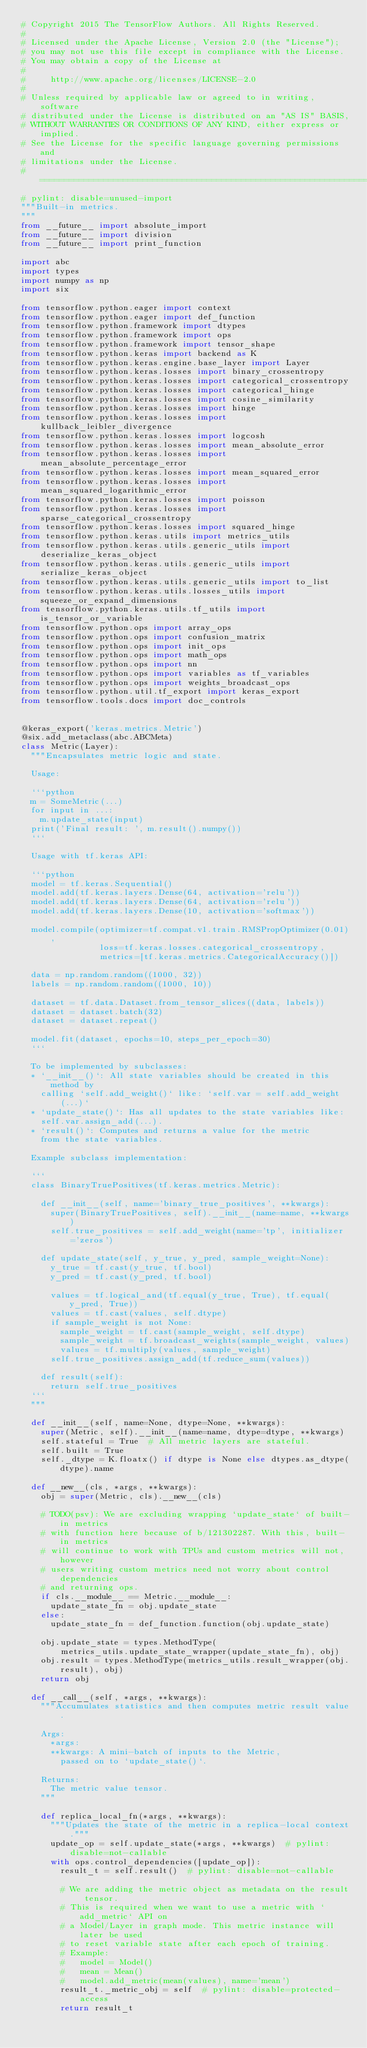Convert code to text. <code><loc_0><loc_0><loc_500><loc_500><_Python_># Copyright 2015 The TensorFlow Authors. All Rights Reserved.
#
# Licensed under the Apache License, Version 2.0 (the "License");
# you may not use this file except in compliance with the License.
# You may obtain a copy of the License at
#
#     http://www.apache.org/licenses/LICENSE-2.0
#
# Unless required by applicable law or agreed to in writing, software
# distributed under the License is distributed on an "AS IS" BASIS,
# WITHOUT WARRANTIES OR CONDITIONS OF ANY KIND, either express or implied.
# See the License for the specific language governing permissions and
# limitations under the License.
# ==============================================================================
# pylint: disable=unused-import
"""Built-in metrics.
"""
from __future__ import absolute_import
from __future__ import division
from __future__ import print_function

import abc
import types
import numpy as np
import six

from tensorflow.python.eager import context
from tensorflow.python.eager import def_function
from tensorflow.python.framework import dtypes
from tensorflow.python.framework import ops
from tensorflow.python.framework import tensor_shape
from tensorflow.python.keras import backend as K
from tensorflow.python.keras.engine.base_layer import Layer
from tensorflow.python.keras.losses import binary_crossentropy
from tensorflow.python.keras.losses import categorical_crossentropy
from tensorflow.python.keras.losses import categorical_hinge
from tensorflow.python.keras.losses import cosine_similarity
from tensorflow.python.keras.losses import hinge
from tensorflow.python.keras.losses import kullback_leibler_divergence
from tensorflow.python.keras.losses import logcosh
from tensorflow.python.keras.losses import mean_absolute_error
from tensorflow.python.keras.losses import mean_absolute_percentage_error
from tensorflow.python.keras.losses import mean_squared_error
from tensorflow.python.keras.losses import mean_squared_logarithmic_error
from tensorflow.python.keras.losses import poisson
from tensorflow.python.keras.losses import sparse_categorical_crossentropy
from tensorflow.python.keras.losses import squared_hinge
from tensorflow.python.keras.utils import metrics_utils
from tensorflow.python.keras.utils.generic_utils import deserialize_keras_object
from tensorflow.python.keras.utils.generic_utils import serialize_keras_object
from tensorflow.python.keras.utils.generic_utils import to_list
from tensorflow.python.keras.utils.losses_utils import squeeze_or_expand_dimensions
from tensorflow.python.keras.utils.tf_utils import is_tensor_or_variable
from tensorflow.python.ops import array_ops
from tensorflow.python.ops import confusion_matrix
from tensorflow.python.ops import init_ops
from tensorflow.python.ops import math_ops
from tensorflow.python.ops import nn
from tensorflow.python.ops import variables as tf_variables
from tensorflow.python.ops import weights_broadcast_ops
from tensorflow.python.util.tf_export import keras_export
from tensorflow.tools.docs import doc_controls


@keras_export('keras.metrics.Metric')
@six.add_metaclass(abc.ABCMeta)
class Metric(Layer):
  """Encapsulates metric logic and state.

  Usage:

  ```python
  m = SomeMetric(...)
  for input in ...:
    m.update_state(input)
  print('Final result: ', m.result().numpy())
  ```

  Usage with tf.keras API:

  ```python
  model = tf.keras.Sequential()
  model.add(tf.keras.layers.Dense(64, activation='relu'))
  model.add(tf.keras.layers.Dense(64, activation='relu'))
  model.add(tf.keras.layers.Dense(10, activation='softmax'))

  model.compile(optimizer=tf.compat.v1.train.RMSPropOptimizer(0.01),
                loss=tf.keras.losses.categorical_crossentropy,
                metrics=[tf.keras.metrics.CategoricalAccuracy()])

  data = np.random.random((1000, 32))
  labels = np.random.random((1000, 10))

  dataset = tf.data.Dataset.from_tensor_slices((data, labels))
  dataset = dataset.batch(32)
  dataset = dataset.repeat()

  model.fit(dataset, epochs=10, steps_per_epoch=30)
  ```

  To be implemented by subclasses:
  * `__init__()`: All state variables should be created in this method by
    calling `self.add_weight()` like: `self.var = self.add_weight(...)`
  * `update_state()`: Has all updates to the state variables like:
    self.var.assign_add(...).
  * `result()`: Computes and returns a value for the metric
    from the state variables.

  Example subclass implementation:

  ```
  class BinaryTruePositives(tf.keras.metrics.Metric):

    def __init__(self, name='binary_true_positives', **kwargs):
      super(BinaryTruePositives, self).__init__(name=name, **kwargs)
      self.true_positives = self.add_weight(name='tp', initializer='zeros')

    def update_state(self, y_true, y_pred, sample_weight=None):
      y_true = tf.cast(y_true, tf.bool)
      y_pred = tf.cast(y_pred, tf.bool)

      values = tf.logical_and(tf.equal(y_true, True), tf.equal(y_pred, True))
      values = tf.cast(values, self.dtype)
      if sample_weight is not None:
        sample_weight = tf.cast(sample_weight, self.dtype)
        sample_weight = tf.broadcast_weights(sample_weight, values)
        values = tf.multiply(values, sample_weight)
      self.true_positives.assign_add(tf.reduce_sum(values))

    def result(self):
      return self.true_positives
  ```
  """

  def __init__(self, name=None, dtype=None, **kwargs):
    super(Metric, self).__init__(name=name, dtype=dtype, **kwargs)
    self.stateful = True  # All metric layers are stateful.
    self.built = True
    self._dtype = K.floatx() if dtype is None else dtypes.as_dtype(dtype).name

  def __new__(cls, *args, **kwargs):
    obj = super(Metric, cls).__new__(cls)

    # TODO(psv): We are excluding wrapping `update_state` of built-in metrics
    # with function here because of b/121302287. With this, built-in metrics
    # will continue to work with TPUs and custom metrics will not, however
    # users writing custom metrics need not worry about control dependencies
    # and returning ops.
    if cls.__module__ == Metric.__module__:
      update_state_fn = obj.update_state
    else:
      update_state_fn = def_function.function(obj.update_state)

    obj.update_state = types.MethodType(
        metrics_utils.update_state_wrapper(update_state_fn), obj)
    obj.result = types.MethodType(metrics_utils.result_wrapper(obj.result), obj)
    return obj

  def __call__(self, *args, **kwargs):
    """Accumulates statistics and then computes metric result value.

    Args:
      *args:
      **kwargs: A mini-batch of inputs to the Metric,
        passed on to `update_state()`.

    Returns:
      The metric value tensor.
    """

    def replica_local_fn(*args, **kwargs):
      """Updates the state of the metric in a replica-local context."""
      update_op = self.update_state(*args, **kwargs)  # pylint: disable=not-callable
      with ops.control_dependencies([update_op]):
        result_t = self.result()  # pylint: disable=not-callable

        # We are adding the metric object as metadata on the result tensor.
        # This is required when we want to use a metric with `add_metric` API on
        # a Model/Layer in graph mode. This metric instance will later be used
        # to reset variable state after each epoch of training.
        # Example:
        #   model = Model()
        #   mean = Mean()
        #   model.add_metric(mean(values), name='mean')
        result_t._metric_obj = self  # pylint: disable=protected-access
        return result_t
</code> 